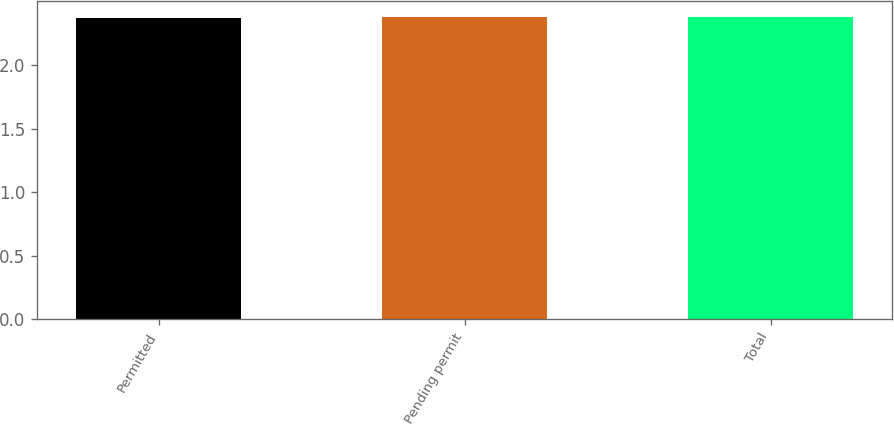Convert chart to OTSL. <chart><loc_0><loc_0><loc_500><loc_500><bar_chart><fcel>Permitted<fcel>Pending permit<fcel>Total<nl><fcel>2.37<fcel>2.38<fcel>2.38<nl></chart> 